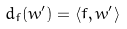Convert formula to latex. <formula><loc_0><loc_0><loc_500><loc_500>d _ { f } ( w ^ { \prime } ) = \langle f , w ^ { \prime } \rangle</formula> 